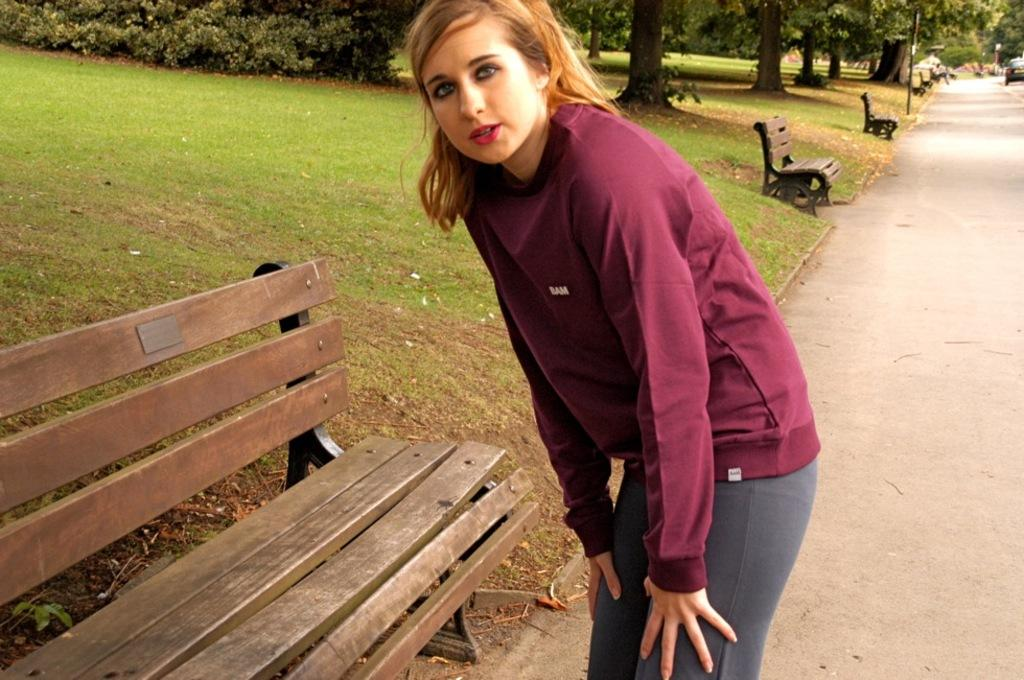Who is present in the image? There is a woman in the image. What is the woman's position in the image? The woman is standing on a path. What is located near the woman? There is a bench near the woman. What can be seen in the background of the image? There is grass, trees, additional benches, and a car in the background of the image. What type of toys can be seen on the ground near the woman? There are no toys visible in the image. Is there a volleyball game taking place in the background of the image? There is no volleyball game or any indication of a volleyball game in the image. 